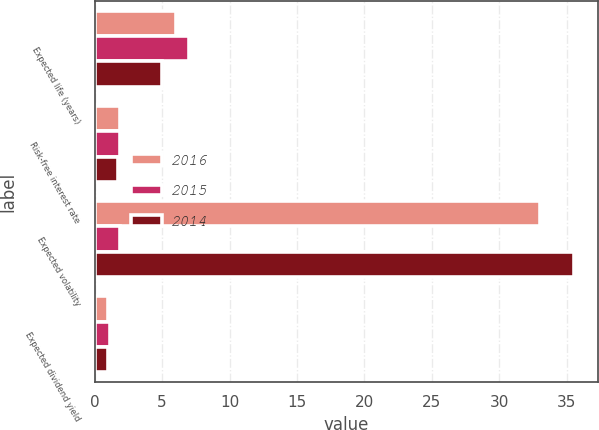Convert chart. <chart><loc_0><loc_0><loc_500><loc_500><stacked_bar_chart><ecel><fcel>Expected life (years)<fcel>Risk-free interest rate<fcel>Expected volatility<fcel>Expected dividend yield<nl><fcel>2016<fcel>6<fcel>1.9<fcel>33<fcel>1<nl><fcel>2015<fcel>7<fcel>1.9<fcel>1.9<fcel>1.1<nl><fcel>2014<fcel>5<fcel>1.7<fcel>35.5<fcel>1<nl></chart> 